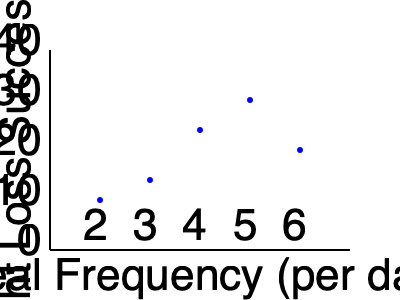Based on the scatter plot, which meal frequency appears to be associated with the highest weight loss success? How might this finding inform your approach to integrating behavioral psychology into diet plans? To answer this question, we need to analyze the scatter plot step-by-step:

1. The x-axis represents meal frequency per day, ranging from 2 to 6 meals.
2. The y-axis represents weight loss success as a percentage, ranging from 0% to 40%.
3. Each point on the plot represents the relationship between meal frequency and weight loss success.
4. We need to identify the highest point on the y-axis, which indicates the highest weight loss success.

Analyzing the data points:
- 2 meals/day: approximately 15% success
- 3 meals/day: approximately 20% success
- 4 meals/day: approximately 30% success
- 5 meals/day: approximately 35% success
- 6 meals/day: approximately 25% success

The highest point on the y-axis corresponds to 5 meals per day, with a weight loss success rate of about 35%.

Integrating this finding with behavioral psychology in diet plans:
1. Meal frequency can significantly impact weight loss success.
2. A higher meal frequency (up to 5 meals/day) appears to be more effective than lower frequencies.
3. This could be due to better appetite control, steady blood sugar levels, or improved metabolism.
4. However, increasing to 6 meals/day shows a decline in success, suggesting there might be an optimal frequency.
5. Behavioral psychology techniques could be used to:
   a. Help clients establish and maintain a 5-meal-per-day eating schedule.
   b. Develop strategies to overcome barriers to frequent, balanced eating.
   c. Create positive associations with this eating pattern.
   d. Address any psychological factors that might influence adherence to this meal frequency.
Answer: 5 meals per day; integrate strategies to establish and maintain this optimal meal frequency using behavioral psychology techniques. 